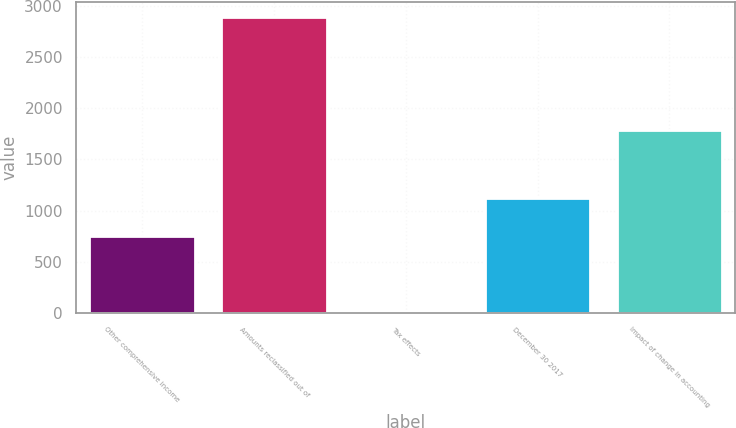<chart> <loc_0><loc_0><loc_500><loc_500><bar_chart><fcel>Other comprehensive income<fcel>Amounts reclassified out of<fcel>Tax effects<fcel>December 30 2017<fcel>Impact of change in accounting<nl><fcel>756<fcel>2890<fcel>3<fcel>1120<fcel>1790<nl></chart> 